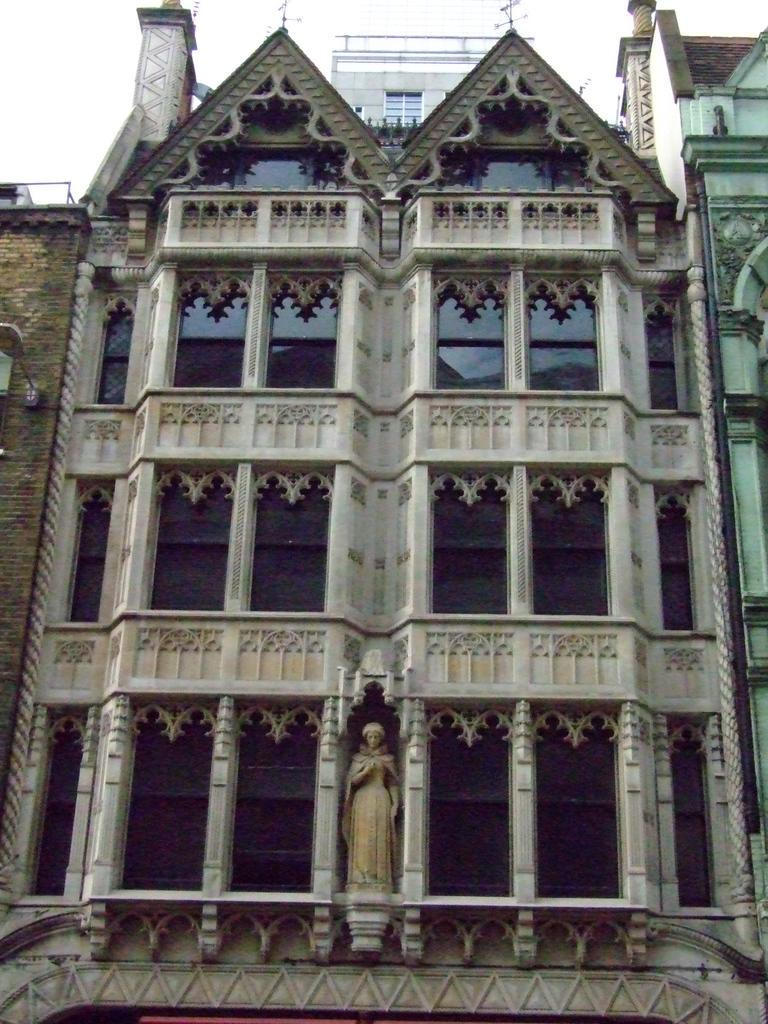What type of structures are present in the image? There are buildings in the image. Can you describe any specific features within the buildings? Yes, there is a statue in the buildings. What is visible in the background of the image? The sky is visible in the background of the image. How many facts can be seen kissing in the image? There are no facts or kissing depicted in the image; it features buildings and a statue. Is there a maid present in the image? There is no maid present in the image. 